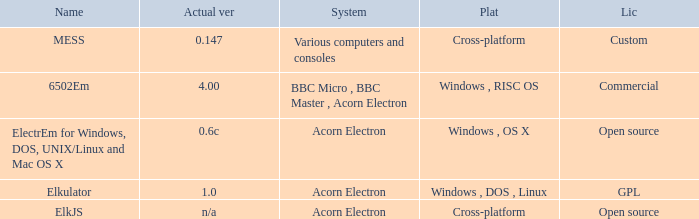What is the name of the platform used for various computers and consoles? Cross-platform. 